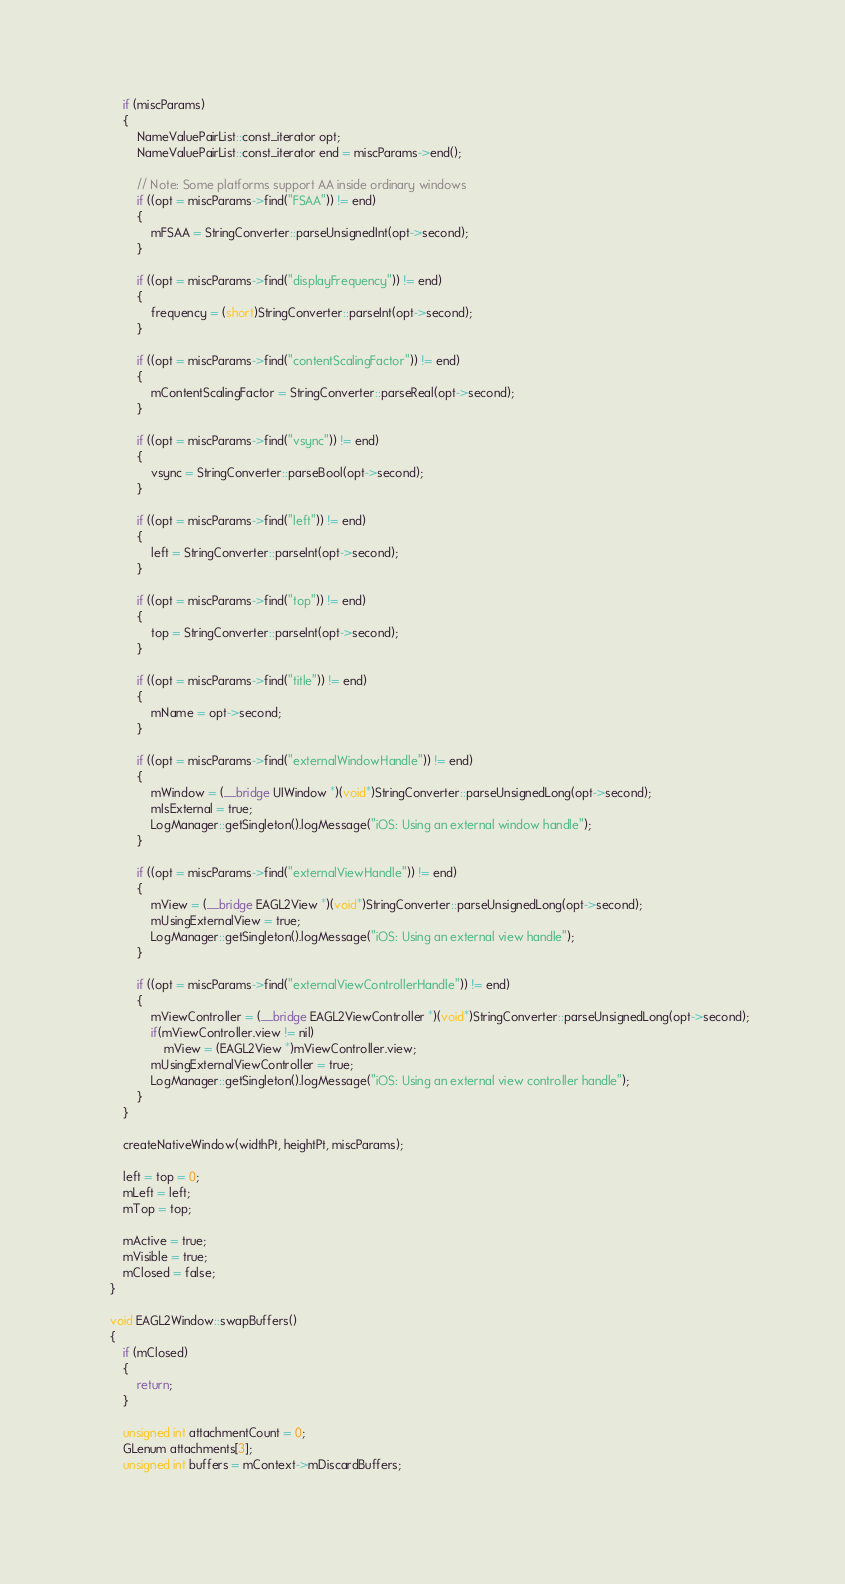<code> <loc_0><loc_0><loc_500><loc_500><_ObjectiveC_>
        if (miscParams)
        {
            NameValuePairList::const_iterator opt;
            NameValuePairList::const_iterator end = miscParams->end();

            // Note: Some platforms support AA inside ordinary windows
            if ((opt = miscParams->find("FSAA")) != end)
            {
                mFSAA = StringConverter::parseUnsignedInt(opt->second);
            }
            
            if ((opt = miscParams->find("displayFrequency")) != end)
            {
                frequency = (short)StringConverter::parseInt(opt->second);
            }

            if ((opt = miscParams->find("contentScalingFactor")) != end)
            {
                mContentScalingFactor = StringConverter::parseReal(opt->second);
            }
            
            if ((opt = miscParams->find("vsync")) != end)
            {
                vsync = StringConverter::parseBool(opt->second);
            }
            
            if ((opt = miscParams->find("left")) != end)
            {
                left = StringConverter::parseInt(opt->second);
            }
            
            if ((opt = miscParams->find("top")) != end)
            {
                top = StringConverter::parseInt(opt->second);
            }
            
            if ((opt = miscParams->find("title")) != end)
            {
                mName = opt->second;
            }

            if ((opt = miscParams->find("externalWindowHandle")) != end)
            {
                mWindow = (__bridge UIWindow *)(void*)StringConverter::parseUnsignedLong(opt->second);
                mIsExternal = true;
                LogManager::getSingleton().logMessage("iOS: Using an external window handle");
            }
        
            if ((opt = miscParams->find("externalViewHandle")) != end)
            {
                mView = (__bridge EAGL2View *)(void*)StringConverter::parseUnsignedLong(opt->second);
                mUsingExternalView = true;
                LogManager::getSingleton().logMessage("iOS: Using an external view handle");
            }
        
            if ((opt = miscParams->find("externalViewControllerHandle")) != end)
            {
                mViewController = (__bridge EAGL2ViewController *)(void*)StringConverter::parseUnsignedLong(opt->second);
                if(mViewController.view != nil)
                    mView = (EAGL2View *)mViewController.view;
                mUsingExternalViewController = true;
                LogManager::getSingleton().logMessage("iOS: Using an external view controller handle");
            }
		}
        
        createNativeWindow(widthPt, heightPt, miscParams);

        left = top = 0;
        mLeft = left;
		mTop = top;

		mActive = true;
		mVisible = true;
		mClosed = false;
    }

    void EAGL2Window::swapBuffers()
    {
        if (mClosed)
        {
            return;
        }

        unsigned int attachmentCount = 0;
        GLenum attachments[3];
        unsigned int buffers = mContext->mDiscardBuffers;
        </code> 